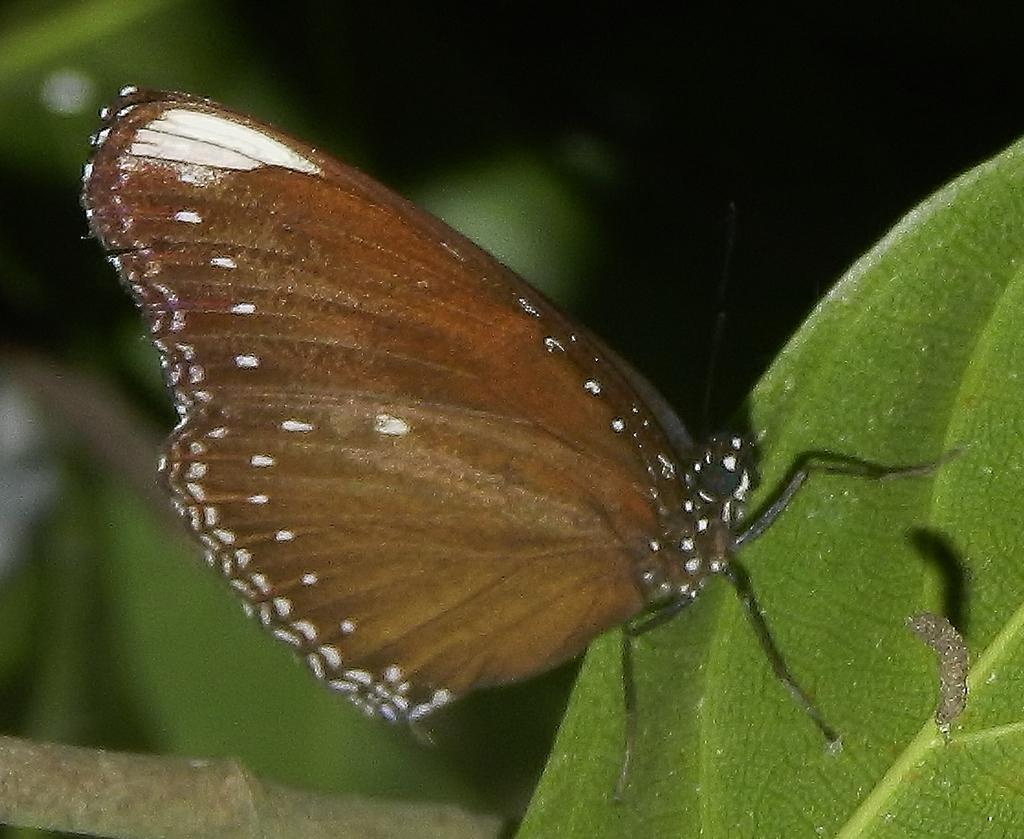What type of animal can be seen in the image? There is a butterfly in the image. Are there any other animals present in the image? Yes, there is an insect in the image. Where are the butterfly and insect located? Both the butterfly and insect are on a leaf. How would you describe the background of the image? The background of the image is blurred. How much tax is being paid by the butterfly in the image? There is no mention of tax in the image, as it features a butterfly and an insect on a leaf. 